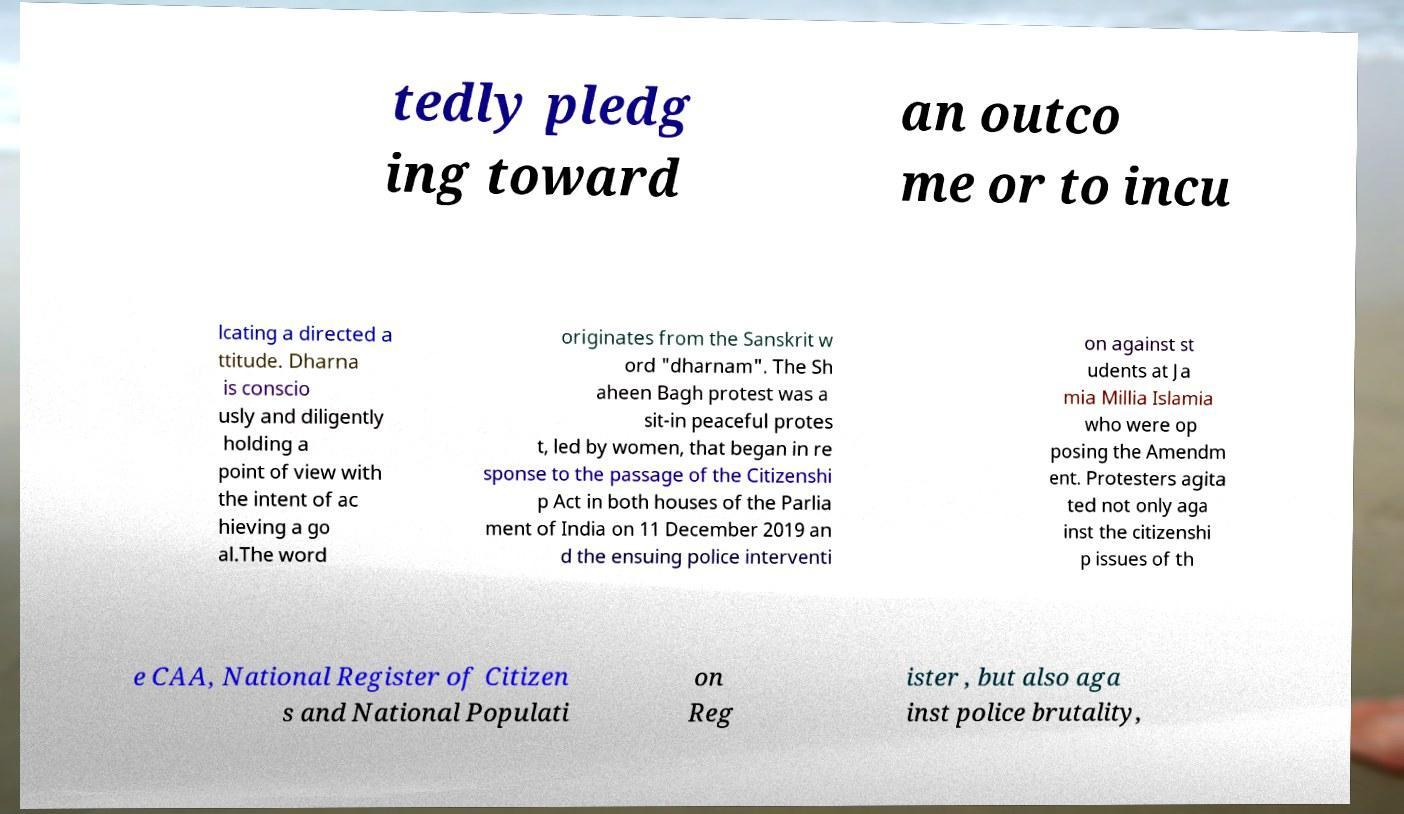Could you assist in decoding the text presented in this image and type it out clearly? tedly pledg ing toward an outco me or to incu lcating a directed a ttitude. Dharna is conscio usly and diligently holding a point of view with the intent of ac hieving a go al.The word originates from the Sanskrit w ord "dharnam". The Sh aheen Bagh protest was a sit-in peaceful protes t, led by women, that began in re sponse to the passage of the Citizenshi p Act in both houses of the Parlia ment of India on 11 December 2019 an d the ensuing police interventi on against st udents at Ja mia Millia Islamia who were op posing the Amendm ent. Protesters agita ted not only aga inst the citizenshi p issues of th e CAA, National Register of Citizen s and National Populati on Reg ister , but also aga inst police brutality, 